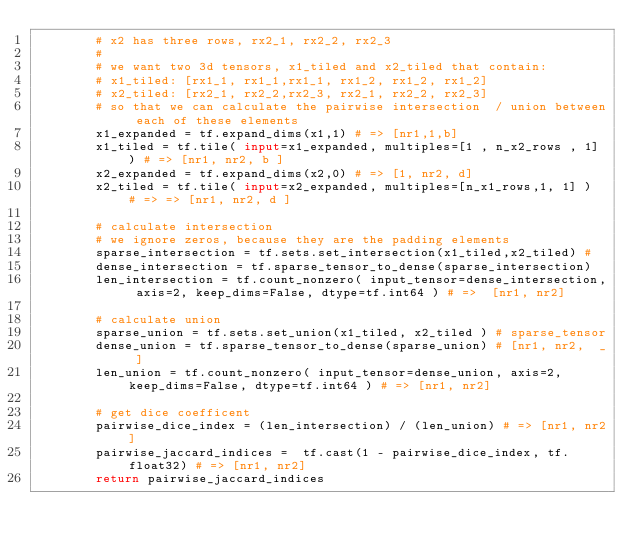<code> <loc_0><loc_0><loc_500><loc_500><_Python_>        # x2 has three rows, rx2_1, rx2_2, rx2_3
        #
        # we want two 3d tensors, x1_tiled and x2_tiled that contain:
        # x1_tiled: [rx1_1, rx1_1,rx1_1, rx1_2, rx1_2, rx1_2] 
        # x2_tiled: [rx2_1, rx2_2,rx2_3, rx2_1, rx2_2, rx2_3] 
        # so that we can calculate the pairwise intersection  / union between each of these elements
        x1_expanded = tf.expand_dims(x1,1) # => [nr1,1,b] 
        x1_tiled = tf.tile( input=x1_expanded, multiples=[1 , n_x2_rows , 1] ) # => [nr1, nr2, b ]
        x2_expanded = tf.expand_dims(x2,0) # => [1, nr2, d] 
        x2_tiled = tf.tile( input=x2_expanded, multiples=[n_x1_rows,1, 1] )  # => => [nr1, nr2, d ]

        # calculate intersection 
        # we ignore zeros, because they are the padding elements   
        sparse_intersection = tf.sets.set_intersection(x1_tiled,x2_tiled) # 
        dense_intersection = tf.sparse_tensor_to_dense(sparse_intersection) 
        len_intersection = tf.count_nonzero( input_tensor=dense_intersection, axis=2, keep_dims=False, dtype=tf.int64 ) # =>  [nr1, nr2]       
       
        # calculate union
        sparse_union = tf.sets.set_union(x1_tiled, x2_tiled ) # sparse_tensor
        dense_union = tf.sparse_tensor_to_dense(sparse_union) # [nr1, nr2,  _ ]
        len_union = tf.count_nonzero( input_tensor=dense_union, axis=2, keep_dims=False, dtype=tf.int64 ) # => [nr1, nr2]

        # get dice coefficent
        pairwise_dice_index = (len_intersection) / (len_union) # => [nr1, nr2]
        pairwise_jaccard_indices =  tf.cast(1 - pairwise_dice_index, tf.float32) # => [nr1, nr2]
        return pairwise_jaccard_indices

    </code> 